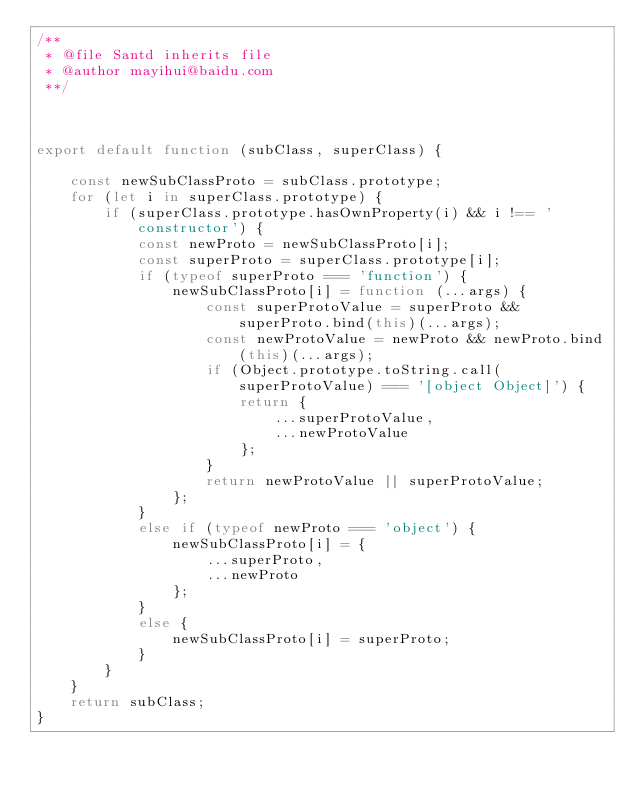Convert code to text. <code><loc_0><loc_0><loc_500><loc_500><_JavaScript_>/**
 * @file Santd inherits file
 * @author mayihui@baidu.com
 **/



export default function (subClass, superClass) {

    const newSubClassProto = subClass.prototype;
    for (let i in superClass.prototype) {
        if (superClass.prototype.hasOwnProperty(i) && i !== 'constructor') {
            const newProto = newSubClassProto[i];
            const superProto = superClass.prototype[i];
            if (typeof superProto === 'function') {
                newSubClassProto[i] = function (...args) {
                    const superProtoValue = superProto && superProto.bind(this)(...args);
                    const newProtoValue = newProto && newProto.bind(this)(...args);
                    if (Object.prototype.toString.call(superProtoValue) === '[object Object]') {
                        return {
                            ...superProtoValue,
                            ...newProtoValue
                        };
                    }
                    return newProtoValue || superProtoValue;
                };
            }
            else if (typeof newProto === 'object') {
                newSubClassProto[i] = {
                    ...superProto,
                    ...newProto
                };
            }
            else {
                newSubClassProto[i] = superProto;
            }
        }
    }
    return subClass;
}</code> 